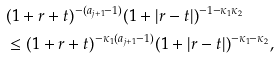<formula> <loc_0><loc_0><loc_500><loc_500>& ( 1 + r + t ) ^ { - ( a _ { j + 1 } - 1 ) } ( 1 + | r - t | ) ^ { - 1 - \kappa _ { 1 } \kappa _ { 2 } } \\ & \leq ( 1 + r + t ) ^ { - \kappa _ { 1 } ( a _ { j + 1 } - 1 ) } ( 1 + | r - t | ) ^ { - \kappa _ { 1 } - \kappa _ { 2 } } ,</formula> 